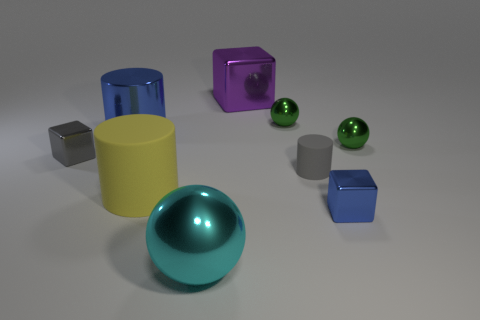Does the sphere on the left side of the big purple shiny thing have the same color as the tiny rubber object?
Make the answer very short. No. There is another shiny thing that is the same shape as the large yellow object; what is its size?
Provide a succinct answer. Large. How many red cubes have the same material as the tiny blue cube?
Provide a succinct answer. 0. There is a large yellow cylinder that is on the right side of the small metal cube that is to the left of the big cyan thing; are there any large blue metal things that are right of it?
Your response must be concise. No. There is a cyan thing; what shape is it?
Offer a terse response. Sphere. Are the large cylinder that is in front of the small gray metal block and the gray thing that is on the right side of the tiny gray block made of the same material?
Your answer should be compact. Yes. How many big balls have the same color as the big cube?
Keep it short and to the point. 0. There is a large metal object that is both left of the large purple object and behind the tiny blue cube; what shape is it?
Offer a very short reply. Cylinder. What color is the shiny thing that is left of the big cyan ball and right of the gray metal thing?
Your answer should be compact. Blue. Are there more small gray matte objects to the left of the big yellow rubber cylinder than small gray matte things that are left of the tiny gray rubber cylinder?
Offer a terse response. No. 